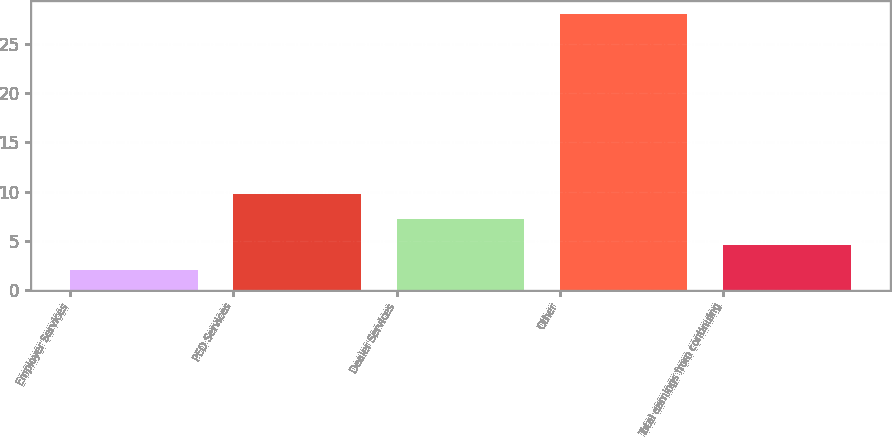Convert chart. <chart><loc_0><loc_0><loc_500><loc_500><bar_chart><fcel>Employer Services<fcel>PEO Services<fcel>Dealer Services<fcel>Other<fcel>Total earnings from continuing<nl><fcel>2<fcel>9.8<fcel>7.2<fcel>28<fcel>4.6<nl></chart> 